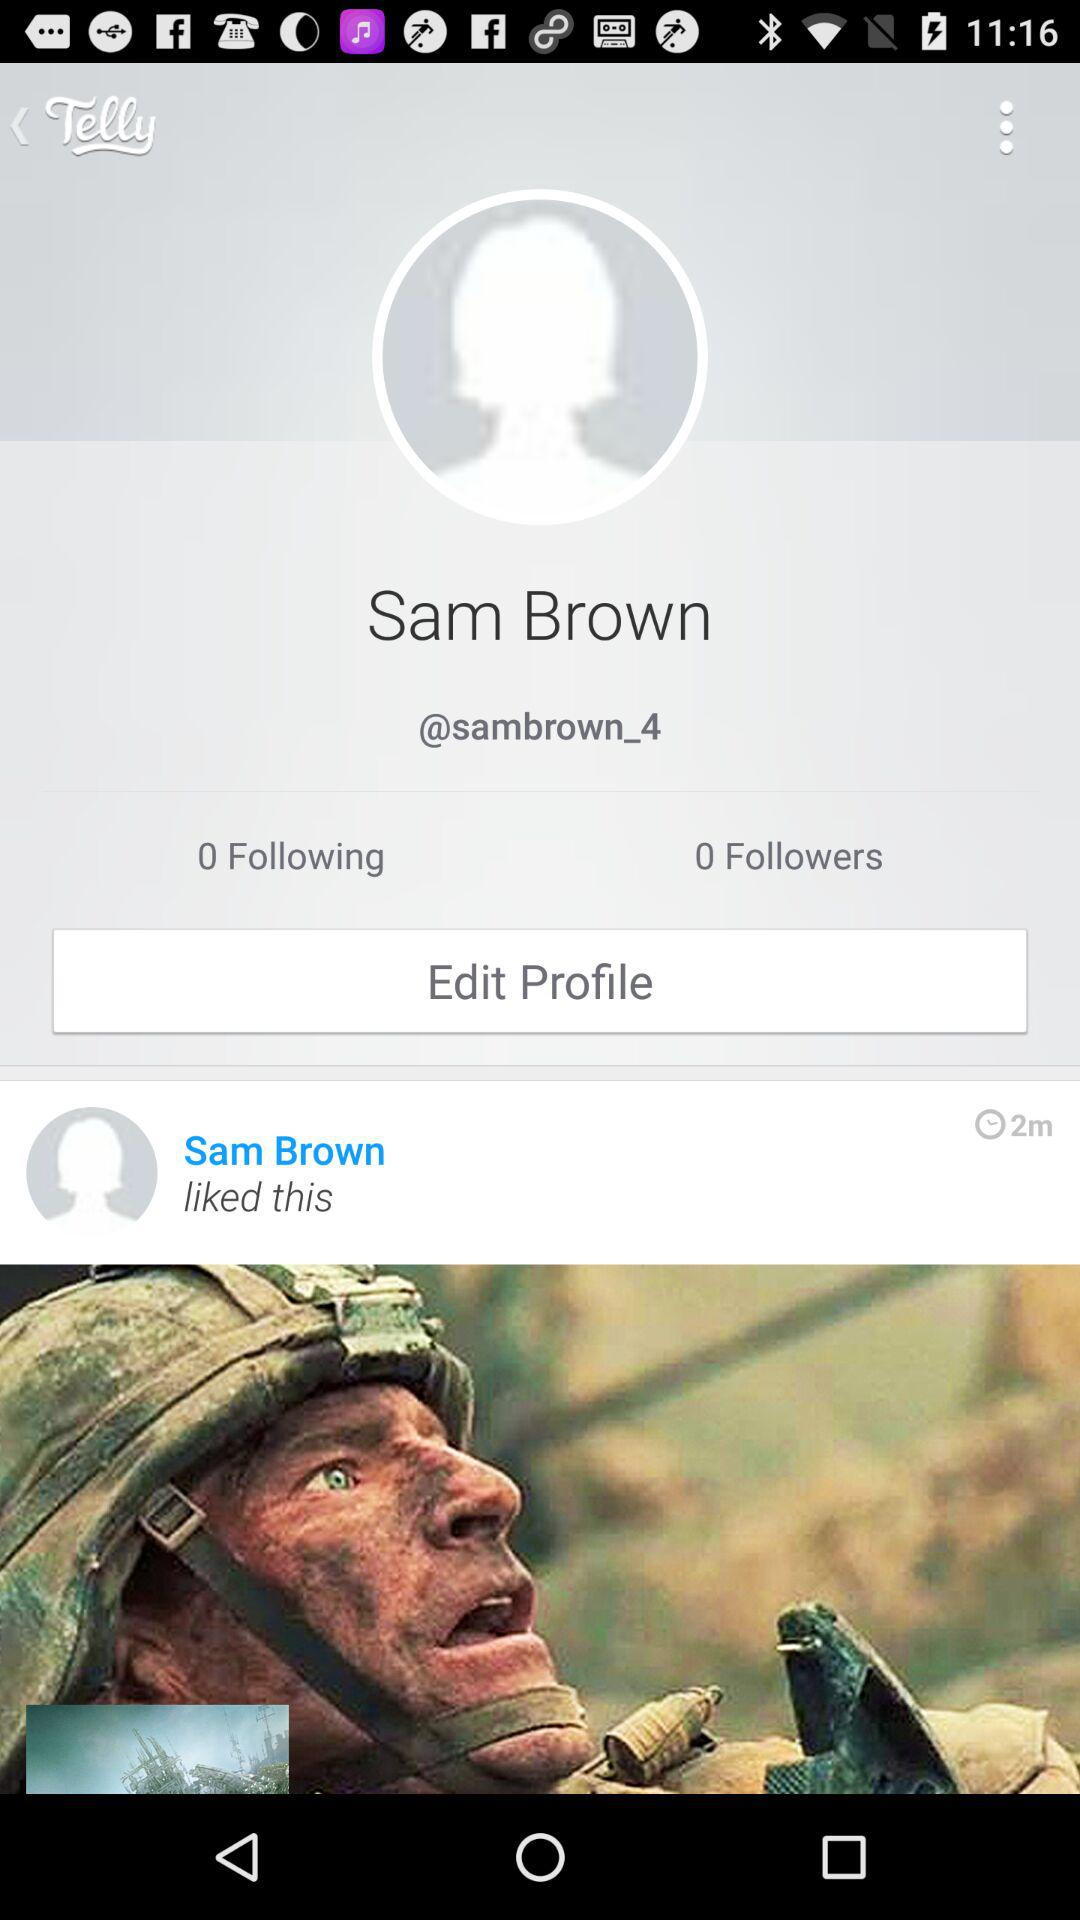How many minutes ago was the post liked?
Answer the question using a single word or phrase. 2 